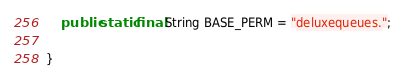Convert code to text. <code><loc_0><loc_0><loc_500><loc_500><_Java_>
    public static final String BASE_PERM = "deluxequeues.";

}
</code> 